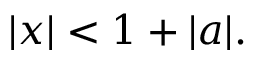<formula> <loc_0><loc_0><loc_500><loc_500>| x | < 1 + | a | .</formula> 